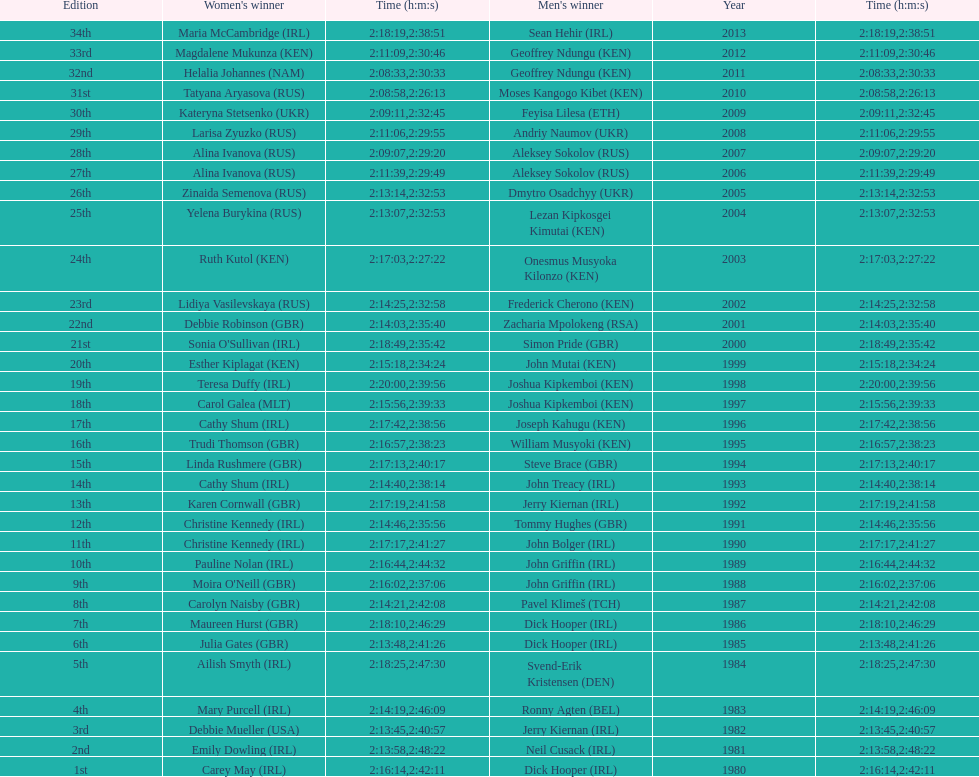Can you parse all the data within this table? {'header': ['Edition', "Women's winner", 'Time (h:m:s)', "Men's winner", 'Year', 'Time (h:m:s)'], 'rows': [['34th', 'Maria McCambridge\xa0(IRL)', '2:18:19', 'Sean Hehir\xa0(IRL)', '2013', '2:38:51'], ['33rd', 'Magdalene Mukunza\xa0(KEN)', '2:11:09', 'Geoffrey Ndungu\xa0(KEN)', '2012', '2:30:46'], ['32nd', 'Helalia Johannes\xa0(NAM)', '2:08:33', 'Geoffrey Ndungu\xa0(KEN)', '2011', '2:30:33'], ['31st', 'Tatyana Aryasova\xa0(RUS)', '2:08:58', 'Moses Kangogo Kibet\xa0(KEN)', '2010', '2:26:13'], ['30th', 'Kateryna Stetsenko\xa0(UKR)', '2:09:11', 'Feyisa Lilesa\xa0(ETH)', '2009', '2:32:45'], ['29th', 'Larisa Zyuzko\xa0(RUS)', '2:11:06', 'Andriy Naumov\xa0(UKR)', '2008', '2:29:55'], ['28th', 'Alina Ivanova\xa0(RUS)', '2:09:07', 'Aleksey Sokolov\xa0(RUS)', '2007', '2:29:20'], ['27th', 'Alina Ivanova\xa0(RUS)', '2:11:39', 'Aleksey Sokolov\xa0(RUS)', '2006', '2:29:49'], ['26th', 'Zinaida Semenova\xa0(RUS)', '2:13:14', 'Dmytro Osadchyy\xa0(UKR)', '2005', '2:32:53'], ['25th', 'Yelena Burykina\xa0(RUS)', '2:13:07', 'Lezan Kipkosgei Kimutai\xa0(KEN)', '2004', '2:32:53'], ['24th', 'Ruth Kutol\xa0(KEN)', '2:17:03', 'Onesmus Musyoka Kilonzo\xa0(KEN)', '2003', '2:27:22'], ['23rd', 'Lidiya Vasilevskaya\xa0(RUS)', '2:14:25', 'Frederick Cherono\xa0(KEN)', '2002', '2:32:58'], ['22nd', 'Debbie Robinson\xa0(GBR)', '2:14:03', 'Zacharia Mpolokeng\xa0(RSA)', '2001', '2:35:40'], ['21st', "Sonia O'Sullivan\xa0(IRL)", '2:18:49', 'Simon Pride\xa0(GBR)', '2000', '2:35:42'], ['20th', 'Esther Kiplagat\xa0(KEN)', '2:15:18', 'John Mutai\xa0(KEN)', '1999', '2:34:24'], ['19th', 'Teresa Duffy\xa0(IRL)', '2:20:00', 'Joshua Kipkemboi\xa0(KEN)', '1998', '2:39:56'], ['18th', 'Carol Galea\xa0(MLT)', '2:15:56', 'Joshua Kipkemboi\xa0(KEN)', '1997', '2:39:33'], ['17th', 'Cathy Shum\xa0(IRL)', '2:17:42', 'Joseph Kahugu\xa0(KEN)', '1996', '2:38:56'], ['16th', 'Trudi Thomson\xa0(GBR)', '2:16:57', 'William Musyoki\xa0(KEN)', '1995', '2:38:23'], ['15th', 'Linda Rushmere\xa0(GBR)', '2:17:13', 'Steve Brace\xa0(GBR)', '1994', '2:40:17'], ['14th', 'Cathy Shum\xa0(IRL)', '2:14:40', 'John Treacy\xa0(IRL)', '1993', '2:38:14'], ['13th', 'Karen Cornwall\xa0(GBR)', '2:17:19', 'Jerry Kiernan\xa0(IRL)', '1992', '2:41:58'], ['12th', 'Christine Kennedy\xa0(IRL)', '2:14:46', 'Tommy Hughes\xa0(GBR)', '1991', '2:35:56'], ['11th', 'Christine Kennedy\xa0(IRL)', '2:17:17', 'John Bolger\xa0(IRL)', '1990', '2:41:27'], ['10th', 'Pauline Nolan\xa0(IRL)', '2:16:44', 'John Griffin\xa0(IRL)', '1989', '2:44:32'], ['9th', "Moira O'Neill\xa0(GBR)", '2:16:02', 'John Griffin\xa0(IRL)', '1988', '2:37:06'], ['8th', 'Carolyn Naisby\xa0(GBR)', '2:14:21', 'Pavel Klimeš\xa0(TCH)', '1987', '2:42:08'], ['7th', 'Maureen Hurst\xa0(GBR)', '2:18:10', 'Dick Hooper\xa0(IRL)', '1986', '2:46:29'], ['6th', 'Julia Gates\xa0(GBR)', '2:13:48', 'Dick Hooper\xa0(IRL)', '1985', '2:41:26'], ['5th', 'Ailish Smyth\xa0(IRL)', '2:18:25', 'Svend-Erik Kristensen\xa0(DEN)', '1984', '2:47:30'], ['4th', 'Mary Purcell\xa0(IRL)', '2:14:19', 'Ronny Agten\xa0(BEL)', '1983', '2:46:09'], ['3rd', 'Debbie Mueller\xa0(USA)', '2:13:45', 'Jerry Kiernan\xa0(IRL)', '1982', '2:40:57'], ['2nd', 'Emily Dowling\xa0(IRL)', '2:13:58', 'Neil Cusack\xa0(IRL)', '1981', '2:48:22'], ['1st', 'Carey May\xa0(IRL)', '2:16:14', 'Dick Hooper\xa0(IRL)', '1980', '2:42:11']]} In 2009, which competitor finished faster - the male or the female? Male. 